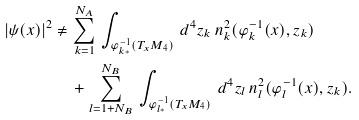<formula> <loc_0><loc_0><loc_500><loc_500>| \psi ( x ) | ^ { 2 } \neq \, & \sum ^ { N _ { A } } _ { k = 1 } \, \int _ { \varphi ^ { - 1 } _ { k * } ( T _ { x } M _ { 4 } ) } \, d ^ { 4 } z _ { k } \, n ^ { 2 } _ { k } ( \varphi ^ { - 1 } _ { k } ( x ) , z _ { k } ) \\ & + \sum ^ { N _ { B } } _ { l = 1 + N _ { B } } \, \int _ { \varphi ^ { - 1 } _ { l * } ( T _ { x } M _ { 4 } ) } \, d ^ { 4 } z _ { l } \, n ^ { 2 } _ { l } ( \varphi ^ { - 1 } _ { l } ( x ) , z _ { k } ) .</formula> 